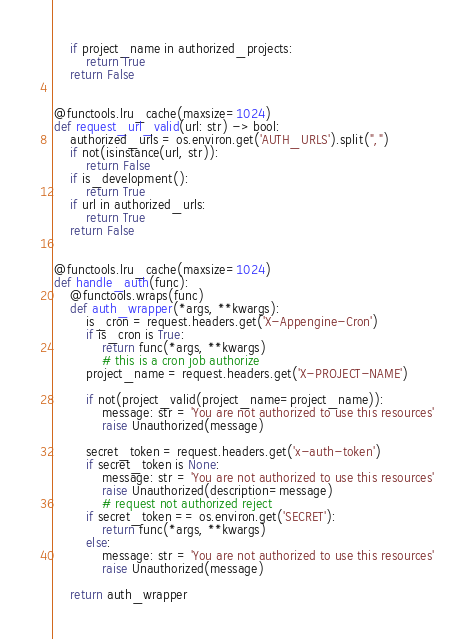<code> <loc_0><loc_0><loc_500><loc_500><_Python_>    if project_name in authorized_projects:
        return True
    return False


@functools.lru_cache(maxsize=1024)
def request_url_valid(url: str) -> bool:
    authorized_urls = os.environ.get('AUTH_URLS').split(",")
    if not(isinstance(url, str)):
        return False
    if is_development():
        return True
    if url in authorized_urls:
        return True
    return False


@functools.lru_cache(maxsize=1024)
def handle_auth(func):
    @functools.wraps(func)
    def auth_wrapper(*args, **kwargs):
        is_cron = request.headers.get('X-Appengine-Cron')
        if is_cron is True:
            return func(*args, **kwargs)
            # this is a cron job authorize
        project_name = request.headers.get('X-PROJECT-NAME')

        if not(project_valid(project_name=project_name)):
            message: str = 'You are not authorized to use this resources'
            raise Unauthorized(message)

        secret_token = request.headers.get('x-auth-token')
        if secret_token is None:
            message: str = 'You are not authorized to use this resources'
            raise Unauthorized(description=message)
            # request not authorized reject
        if secret_token == os.environ.get('SECRET'):
            return func(*args, **kwargs)
        else:
            message: str = 'You are not authorized to use this resources'
            raise Unauthorized(message)

    return auth_wrapper
</code> 